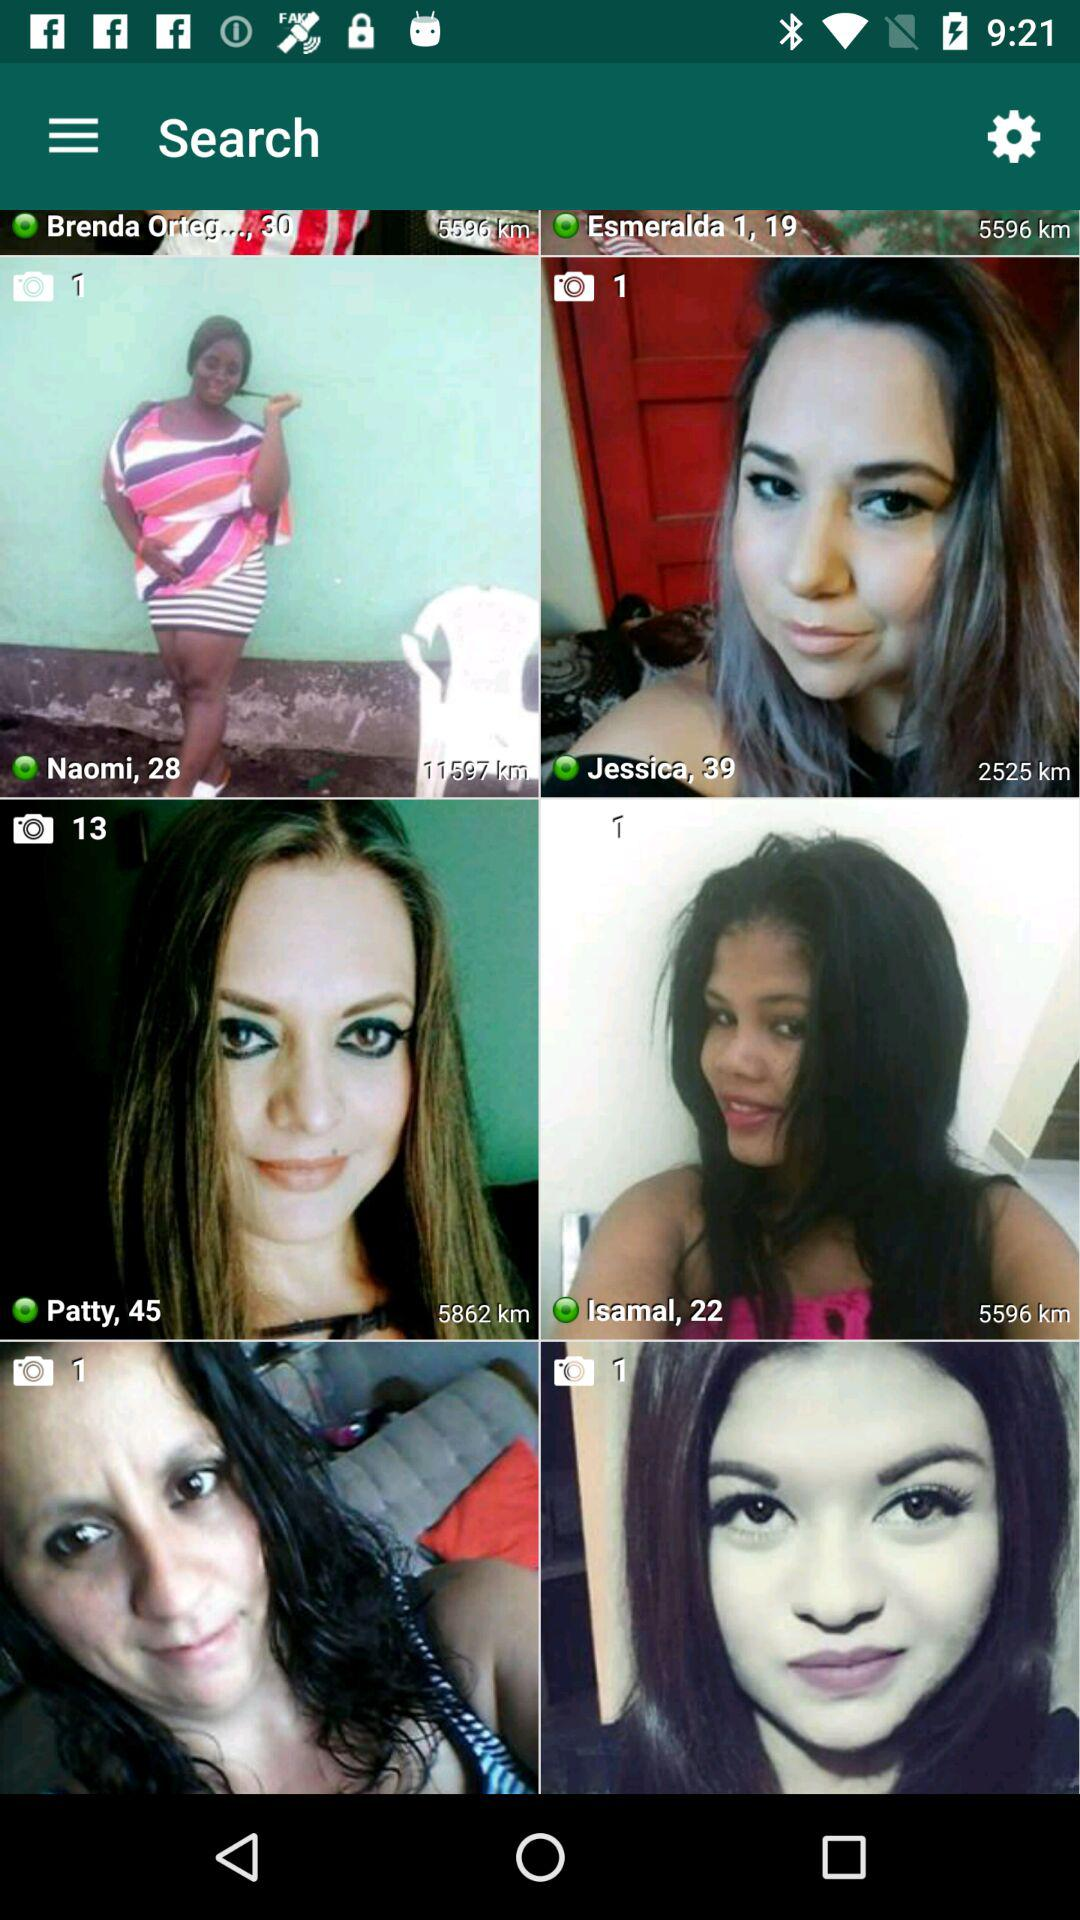How many photos of Patty are there? There are 13 photos. 